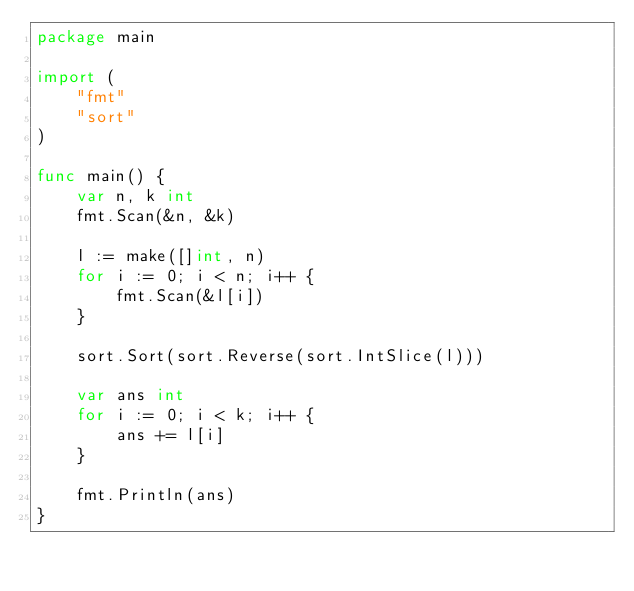Convert code to text. <code><loc_0><loc_0><loc_500><loc_500><_Go_>package main

import (
	"fmt"
	"sort"
)

func main() {
	var n, k int
	fmt.Scan(&n, &k)

	l := make([]int, n)
	for i := 0; i < n; i++ {
		fmt.Scan(&l[i])
	}

	sort.Sort(sort.Reverse(sort.IntSlice(l)))

	var ans int
	for i := 0; i < k; i++ {
		ans += l[i]
	}

	fmt.Println(ans)
}
</code> 